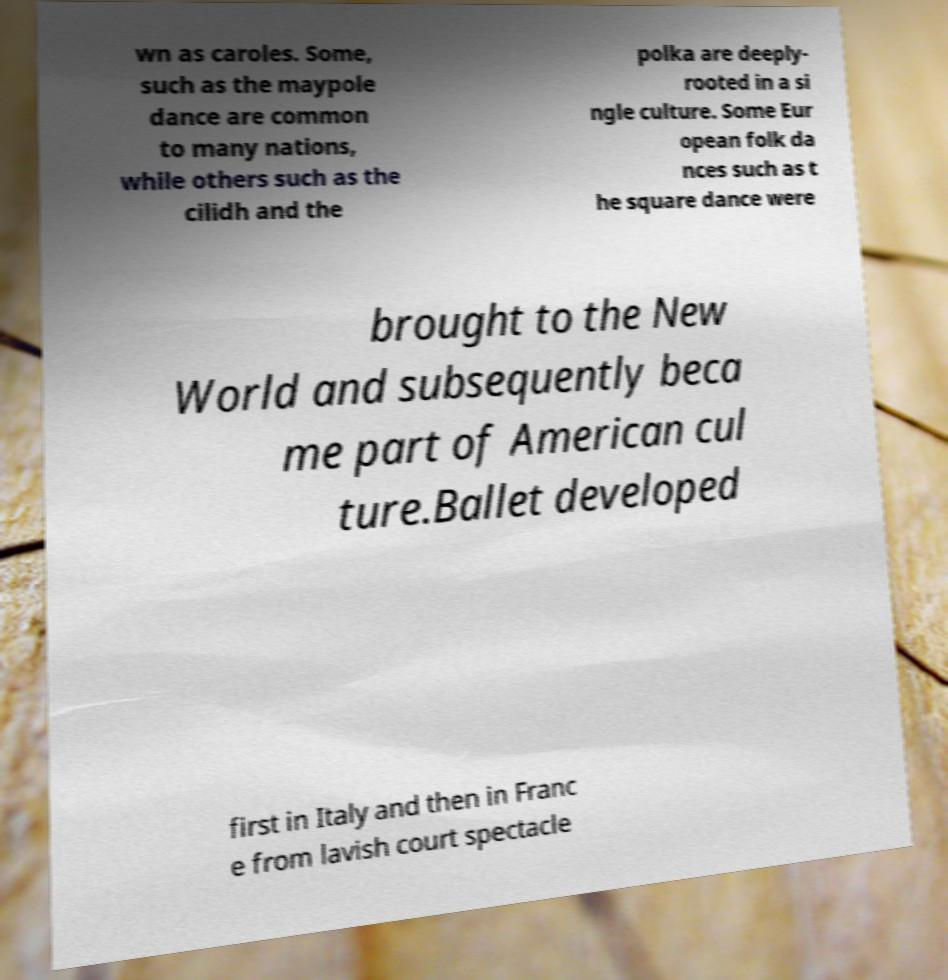Could you extract and type out the text from this image? wn as caroles. Some, such as the maypole dance are common to many nations, while others such as the cilidh and the polka are deeply- rooted in a si ngle culture. Some Eur opean folk da nces such as t he square dance were brought to the New World and subsequently beca me part of American cul ture.Ballet developed first in Italy and then in Franc e from lavish court spectacle 